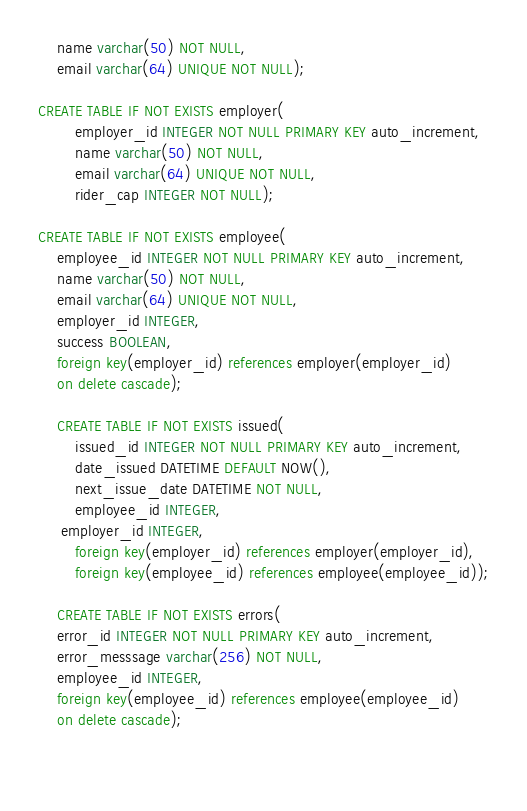Convert code to text. <code><loc_0><loc_0><loc_500><loc_500><_SQL_>    name varchar(50) NOT NULL,
    email varchar(64) UNIQUE NOT NULL);
    
CREATE TABLE IF NOT EXISTS employer(
		employer_id INTEGER NOT NULL PRIMARY KEY auto_increment,
        name varchar(50) NOT NULL,
        email varchar(64) UNIQUE NOT NULL,
        rider_cap INTEGER NOT NULL);
        
CREATE TABLE IF NOT EXISTS employee(
	employee_id INTEGER NOT NULL PRIMARY KEY auto_increment,
    name varchar(50) NOT NULL,
    email varchar(64) UNIQUE NOT NULL,
    employer_id INTEGER,
    success BOOLEAN,
    foreign key(employer_id) references employer(employer_id)
    on delete cascade);
    
    CREATE TABLE IF NOT EXISTS issued(
		issued_id INTEGER NOT NULL PRIMARY KEY auto_increment,
		date_issued DATETIME DEFAULT NOW(),
        next_issue_date DATETIME NOT NULL,
        employee_id INTEGER,
	 employer_id INTEGER,
        foreign key(employer_id) references employer(employer_id),
        foreign key(employee_id) references employee(employee_id));
        
	CREATE TABLE IF NOT EXISTS errors(
    error_id INTEGER NOT NULL PRIMARY KEY auto_increment,
    error_messsage varchar(256) NOT NULL,
    employee_id INTEGER,
    foreign key(employee_id) references employee(employee_id)
    on delete cascade);
        
        
</code> 